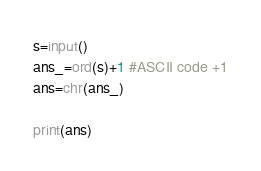<code> <loc_0><loc_0><loc_500><loc_500><_Python_>s=input()
ans_=ord(s)+1 #ASCII code +1
ans=chr(ans_)

print(ans)</code> 